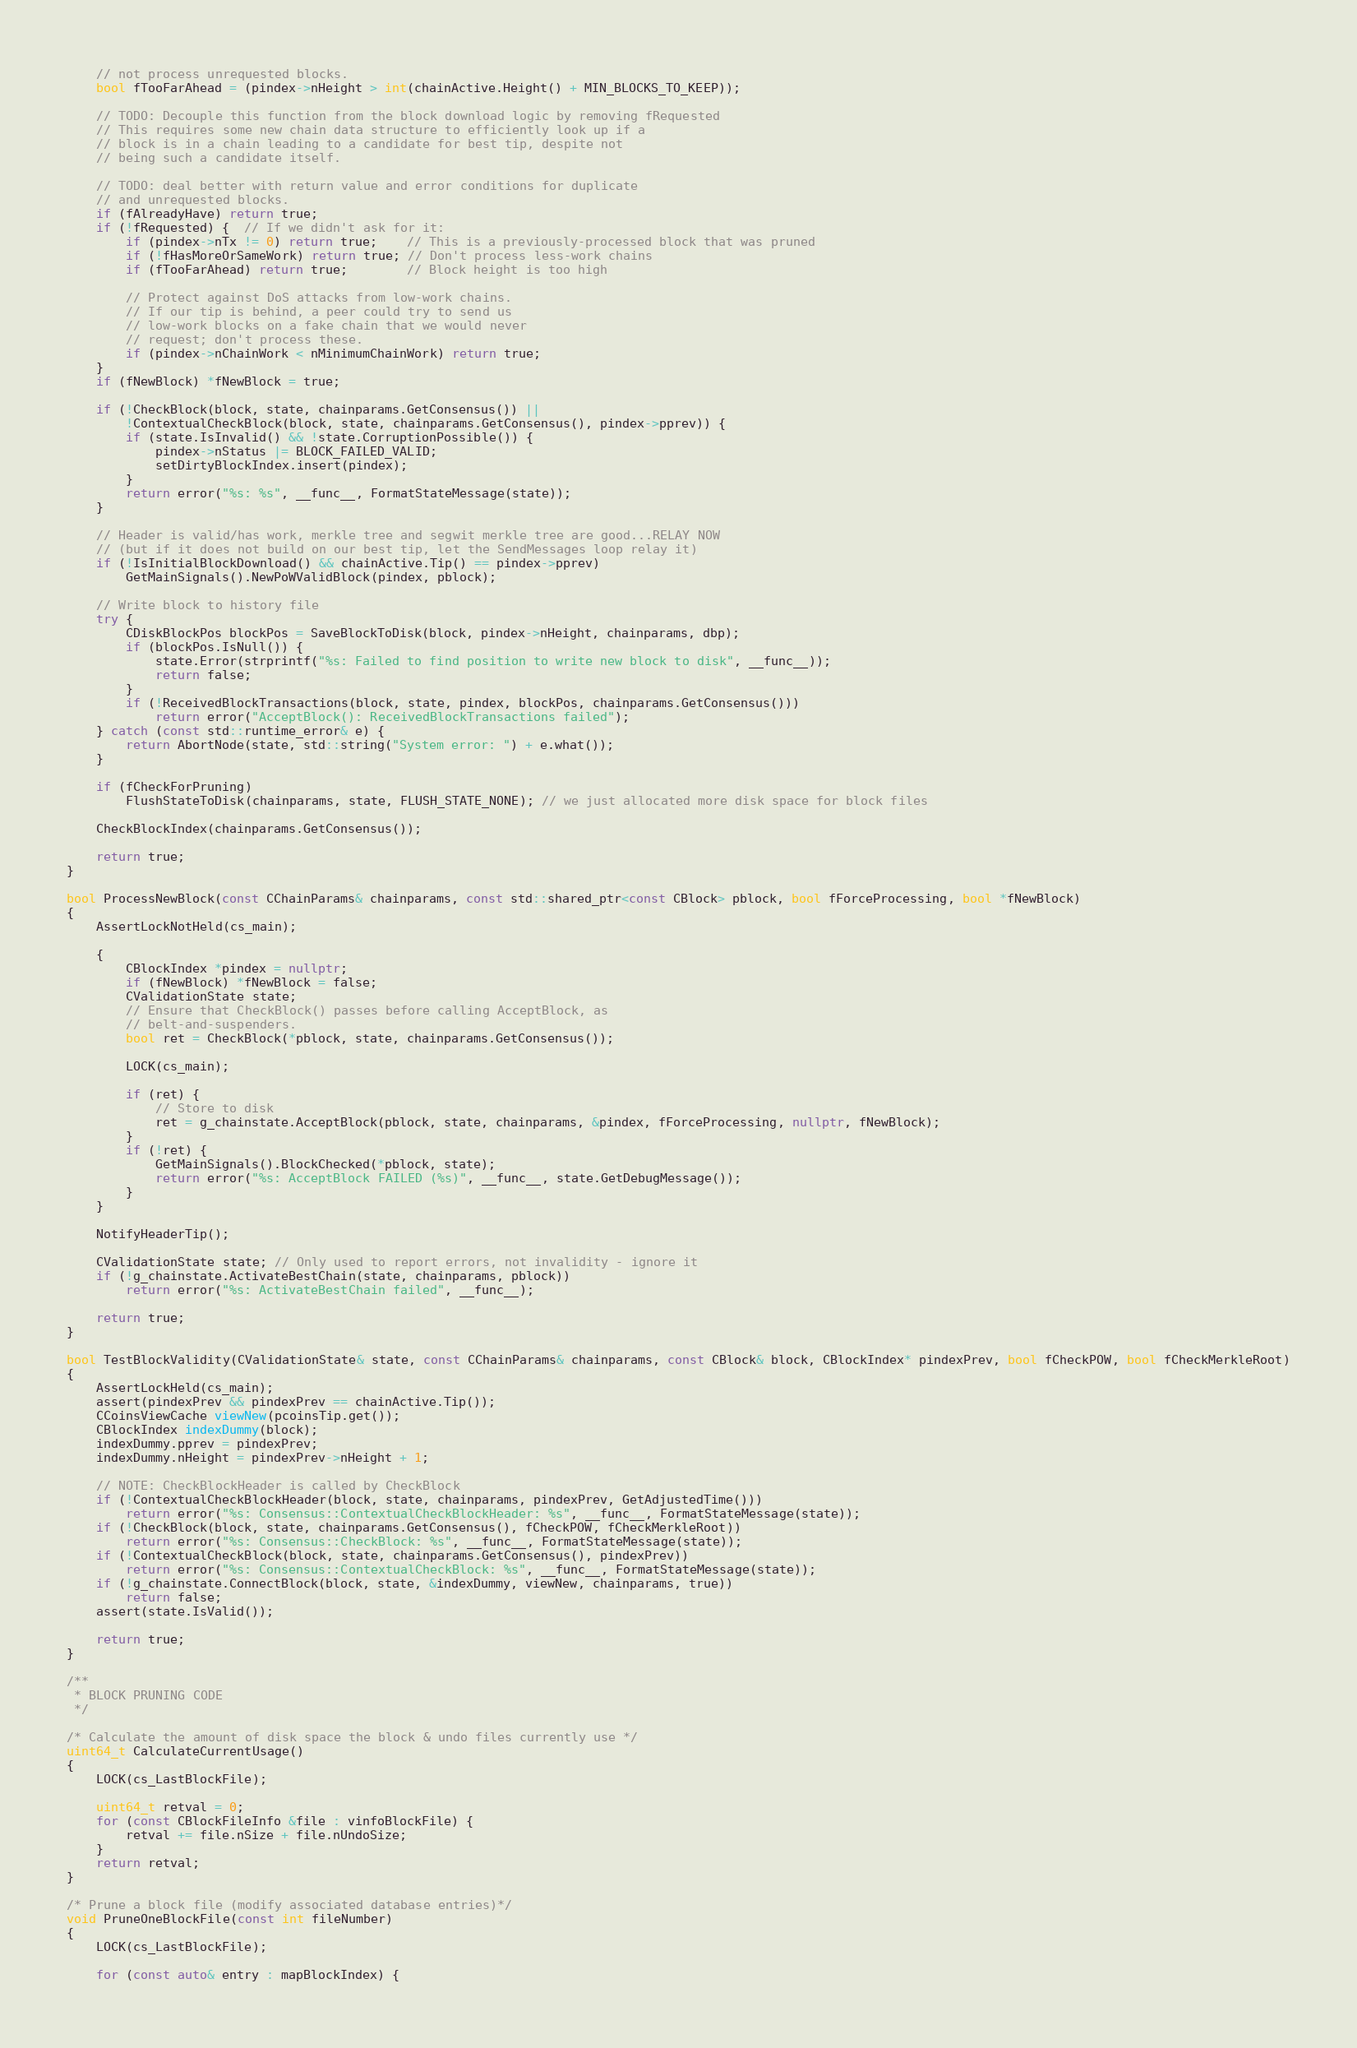<code> <loc_0><loc_0><loc_500><loc_500><_C++_>    // not process unrequested blocks.
    bool fTooFarAhead = (pindex->nHeight > int(chainActive.Height() + MIN_BLOCKS_TO_KEEP));

    // TODO: Decouple this function from the block download logic by removing fRequested
    // This requires some new chain data structure to efficiently look up if a
    // block is in a chain leading to a candidate for best tip, despite not
    // being such a candidate itself.

    // TODO: deal better with return value and error conditions for duplicate
    // and unrequested blocks.
    if (fAlreadyHave) return true;
    if (!fRequested) {  // If we didn't ask for it:
        if (pindex->nTx != 0) return true;    // This is a previously-processed block that was pruned
        if (!fHasMoreOrSameWork) return true; // Don't process less-work chains
        if (fTooFarAhead) return true;        // Block height is too high

        // Protect against DoS attacks from low-work chains.
        // If our tip is behind, a peer could try to send us
        // low-work blocks on a fake chain that we would never
        // request; don't process these.
        if (pindex->nChainWork < nMinimumChainWork) return true;
    }
    if (fNewBlock) *fNewBlock = true;

    if (!CheckBlock(block, state, chainparams.GetConsensus()) ||
        !ContextualCheckBlock(block, state, chainparams.GetConsensus(), pindex->pprev)) {
        if (state.IsInvalid() && !state.CorruptionPossible()) {
            pindex->nStatus |= BLOCK_FAILED_VALID;
            setDirtyBlockIndex.insert(pindex);
        }
        return error("%s: %s", __func__, FormatStateMessage(state));
    }

    // Header is valid/has work, merkle tree and segwit merkle tree are good...RELAY NOW
    // (but if it does not build on our best tip, let the SendMessages loop relay it)
    if (!IsInitialBlockDownload() && chainActive.Tip() == pindex->pprev)
        GetMainSignals().NewPoWValidBlock(pindex, pblock);

    // Write block to history file
    try {
        CDiskBlockPos blockPos = SaveBlockToDisk(block, pindex->nHeight, chainparams, dbp);
        if (blockPos.IsNull()) {
            state.Error(strprintf("%s: Failed to find position to write new block to disk", __func__));
            return false;
        }
        if (!ReceivedBlockTransactions(block, state, pindex, blockPos, chainparams.GetConsensus()))
            return error("AcceptBlock(): ReceivedBlockTransactions failed");
    } catch (const std::runtime_error& e) {
        return AbortNode(state, std::string("System error: ") + e.what());
    }

    if (fCheckForPruning)
        FlushStateToDisk(chainparams, state, FLUSH_STATE_NONE); // we just allocated more disk space for block files

    CheckBlockIndex(chainparams.GetConsensus());

    return true;
}

bool ProcessNewBlock(const CChainParams& chainparams, const std::shared_ptr<const CBlock> pblock, bool fForceProcessing, bool *fNewBlock)
{
    AssertLockNotHeld(cs_main);

    {
        CBlockIndex *pindex = nullptr;
        if (fNewBlock) *fNewBlock = false;
        CValidationState state;
        // Ensure that CheckBlock() passes before calling AcceptBlock, as
        // belt-and-suspenders.
        bool ret = CheckBlock(*pblock, state, chainparams.GetConsensus());

        LOCK(cs_main);

        if (ret) {
            // Store to disk
            ret = g_chainstate.AcceptBlock(pblock, state, chainparams, &pindex, fForceProcessing, nullptr, fNewBlock);
        }
        if (!ret) {
            GetMainSignals().BlockChecked(*pblock, state);
            return error("%s: AcceptBlock FAILED (%s)", __func__, state.GetDebugMessage());
        }
    }

    NotifyHeaderTip();

    CValidationState state; // Only used to report errors, not invalidity - ignore it
    if (!g_chainstate.ActivateBestChain(state, chainparams, pblock))
        return error("%s: ActivateBestChain failed", __func__);

    return true;
}

bool TestBlockValidity(CValidationState& state, const CChainParams& chainparams, const CBlock& block, CBlockIndex* pindexPrev, bool fCheckPOW, bool fCheckMerkleRoot)
{
    AssertLockHeld(cs_main);
    assert(pindexPrev && pindexPrev == chainActive.Tip());
    CCoinsViewCache viewNew(pcoinsTip.get());
    CBlockIndex indexDummy(block);
    indexDummy.pprev = pindexPrev;
    indexDummy.nHeight = pindexPrev->nHeight + 1;

    // NOTE: CheckBlockHeader is called by CheckBlock
    if (!ContextualCheckBlockHeader(block, state, chainparams, pindexPrev, GetAdjustedTime()))
        return error("%s: Consensus::ContextualCheckBlockHeader: %s", __func__, FormatStateMessage(state));
    if (!CheckBlock(block, state, chainparams.GetConsensus(), fCheckPOW, fCheckMerkleRoot))
        return error("%s: Consensus::CheckBlock: %s", __func__, FormatStateMessage(state));
    if (!ContextualCheckBlock(block, state, chainparams.GetConsensus(), pindexPrev))
        return error("%s: Consensus::ContextualCheckBlock: %s", __func__, FormatStateMessage(state));
    if (!g_chainstate.ConnectBlock(block, state, &indexDummy, viewNew, chainparams, true))
        return false;
    assert(state.IsValid());

    return true;
}

/**
 * BLOCK PRUNING CODE
 */

/* Calculate the amount of disk space the block & undo files currently use */
uint64_t CalculateCurrentUsage()
{
    LOCK(cs_LastBlockFile);

    uint64_t retval = 0;
    for (const CBlockFileInfo &file : vinfoBlockFile) {
        retval += file.nSize + file.nUndoSize;
    }
    return retval;
}

/* Prune a block file (modify associated database entries)*/
void PruneOneBlockFile(const int fileNumber)
{
    LOCK(cs_LastBlockFile);

    for (const auto& entry : mapBlockIndex) {</code> 